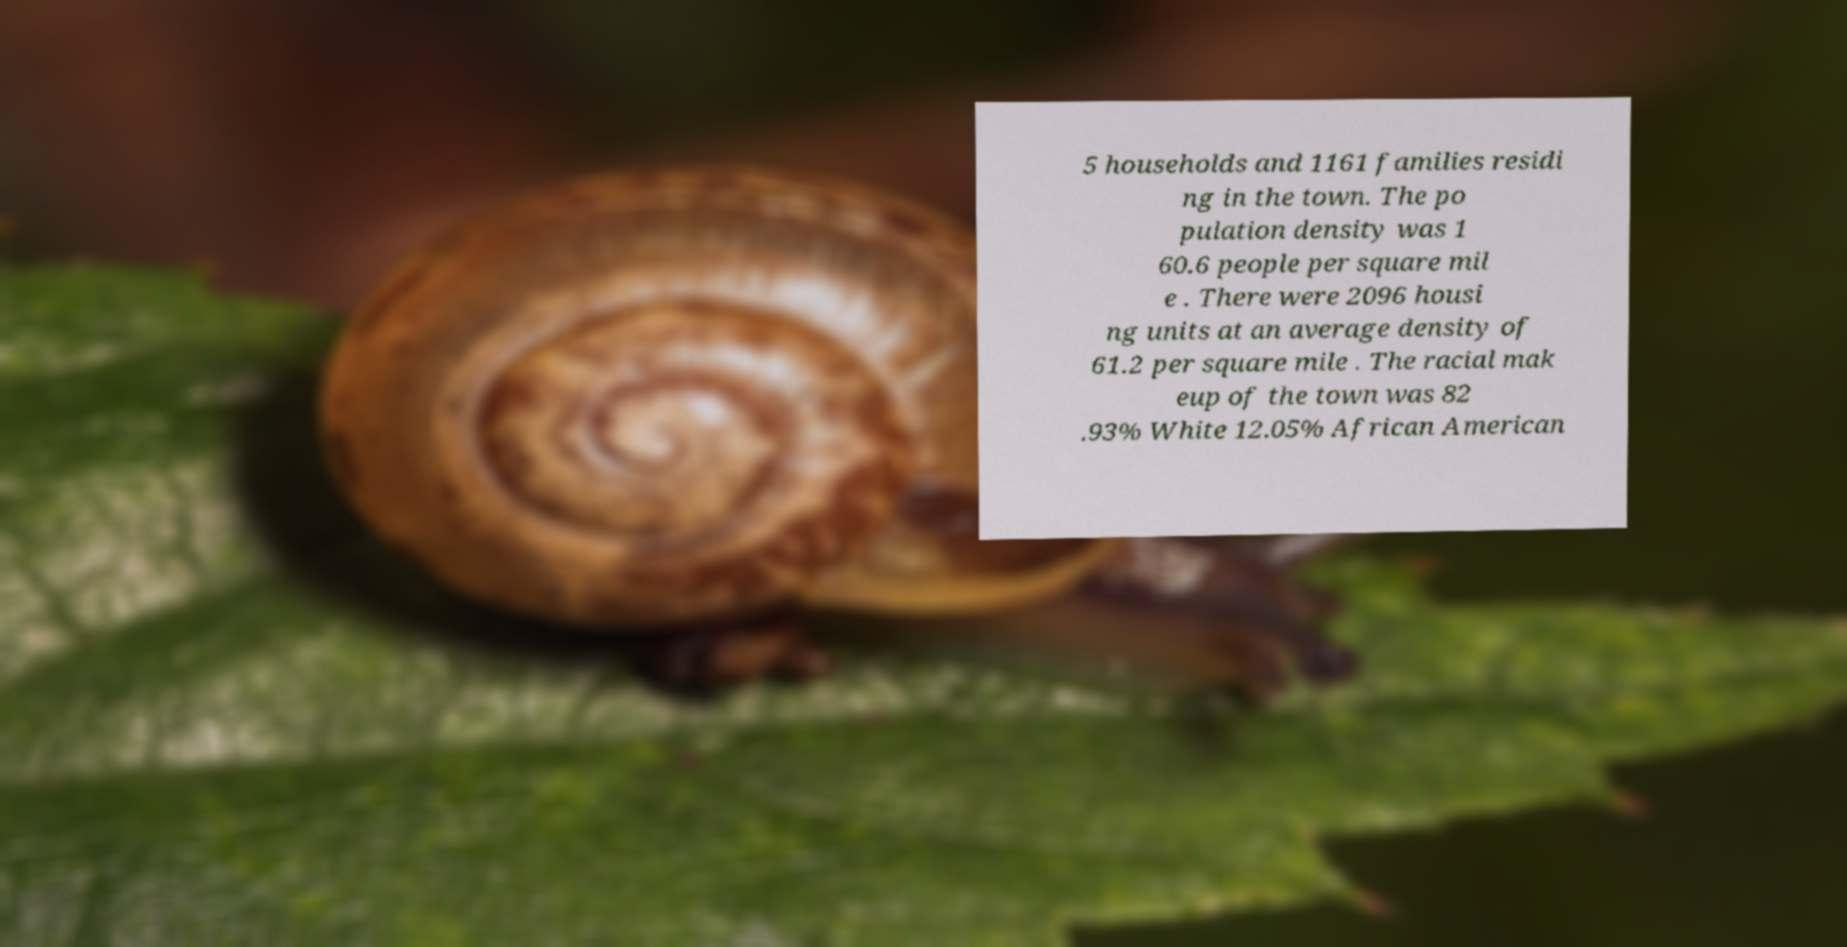Please identify and transcribe the text found in this image. 5 households and 1161 families residi ng in the town. The po pulation density was 1 60.6 people per square mil e . There were 2096 housi ng units at an average density of 61.2 per square mile . The racial mak eup of the town was 82 .93% White 12.05% African American 